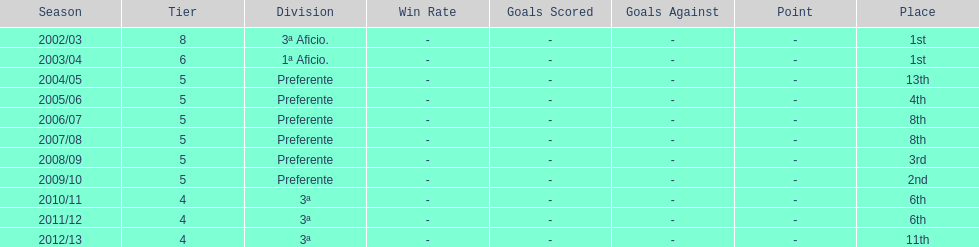How long did the team stay in first place? 2 years. 